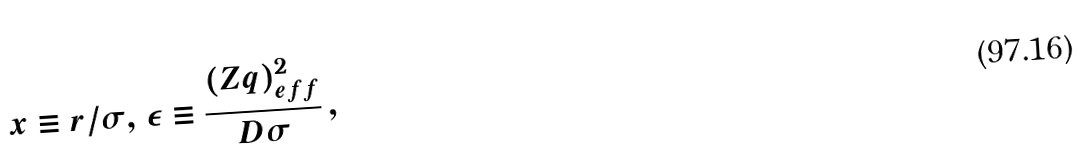Convert formula to latex. <formula><loc_0><loc_0><loc_500><loc_500>x \equiv r / \sigma , \, \epsilon \equiv \frac { ( Z q ) _ { e f f } ^ { 2 } } { D \sigma } \, ,</formula> 